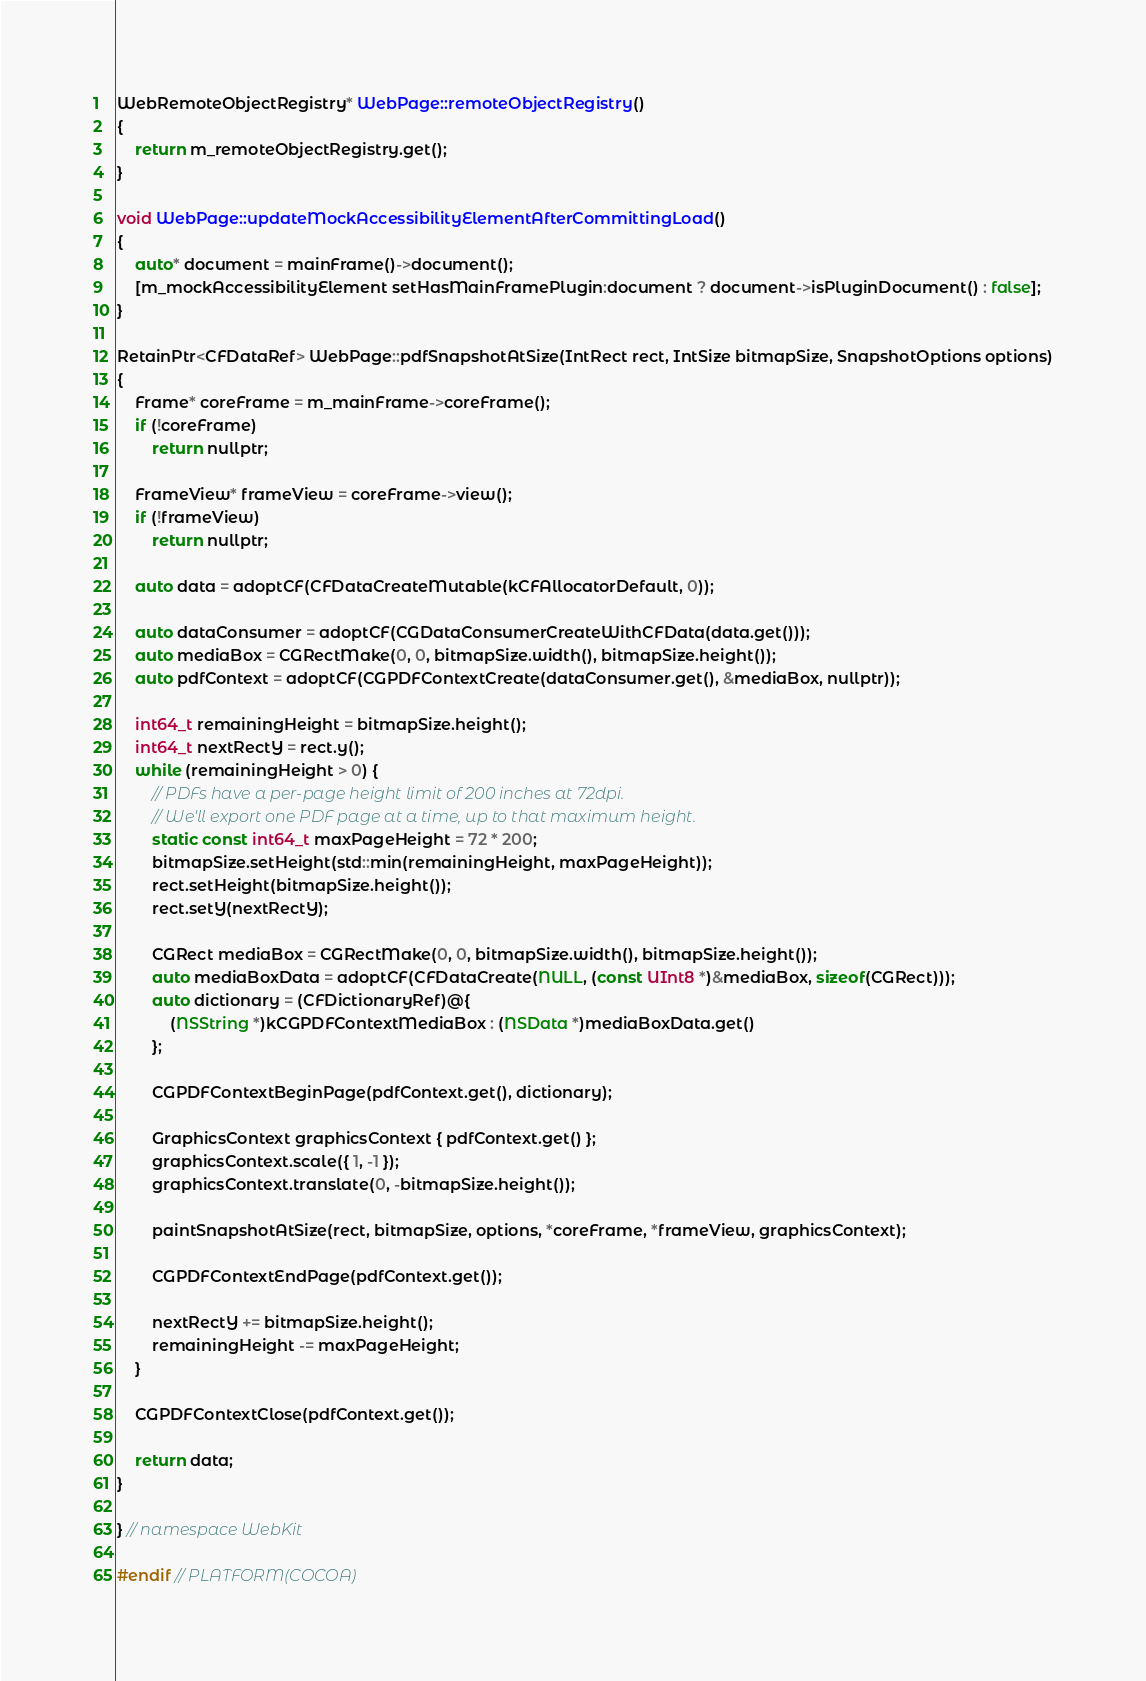<code> <loc_0><loc_0><loc_500><loc_500><_ObjectiveC_>WebRemoteObjectRegistry* WebPage::remoteObjectRegistry()
{
    return m_remoteObjectRegistry.get();
}

void WebPage::updateMockAccessibilityElementAfterCommittingLoad()
{
    auto* document = mainFrame()->document();
    [m_mockAccessibilityElement setHasMainFramePlugin:document ? document->isPluginDocument() : false];
}

RetainPtr<CFDataRef> WebPage::pdfSnapshotAtSize(IntRect rect, IntSize bitmapSize, SnapshotOptions options)
{
    Frame* coreFrame = m_mainFrame->coreFrame();
    if (!coreFrame)
        return nullptr;

    FrameView* frameView = coreFrame->view();
    if (!frameView)
        return nullptr;

    auto data = adoptCF(CFDataCreateMutable(kCFAllocatorDefault, 0));

    auto dataConsumer = adoptCF(CGDataConsumerCreateWithCFData(data.get()));
    auto mediaBox = CGRectMake(0, 0, bitmapSize.width(), bitmapSize.height());
    auto pdfContext = adoptCF(CGPDFContextCreate(dataConsumer.get(), &mediaBox, nullptr));

    int64_t remainingHeight = bitmapSize.height();
    int64_t nextRectY = rect.y();
    while (remainingHeight > 0) {
        // PDFs have a per-page height limit of 200 inches at 72dpi.
        // We'll export one PDF page at a time, up to that maximum height.
        static const int64_t maxPageHeight = 72 * 200;
        bitmapSize.setHeight(std::min(remainingHeight, maxPageHeight));
        rect.setHeight(bitmapSize.height());
        rect.setY(nextRectY);

        CGRect mediaBox = CGRectMake(0, 0, bitmapSize.width(), bitmapSize.height());
        auto mediaBoxData = adoptCF(CFDataCreate(NULL, (const UInt8 *)&mediaBox, sizeof(CGRect)));
        auto dictionary = (CFDictionaryRef)@{
            (NSString *)kCGPDFContextMediaBox : (NSData *)mediaBoxData.get()
        };

        CGPDFContextBeginPage(pdfContext.get(), dictionary);

        GraphicsContext graphicsContext { pdfContext.get() };
        graphicsContext.scale({ 1, -1 });
        graphicsContext.translate(0, -bitmapSize.height());

        paintSnapshotAtSize(rect, bitmapSize, options, *coreFrame, *frameView, graphicsContext);

        CGPDFContextEndPage(pdfContext.get());

        nextRectY += bitmapSize.height();
        remainingHeight -= maxPageHeight;
    }

    CGPDFContextClose(pdfContext.get());

    return data;
}

} // namespace WebKit

#endif // PLATFORM(COCOA)
</code> 